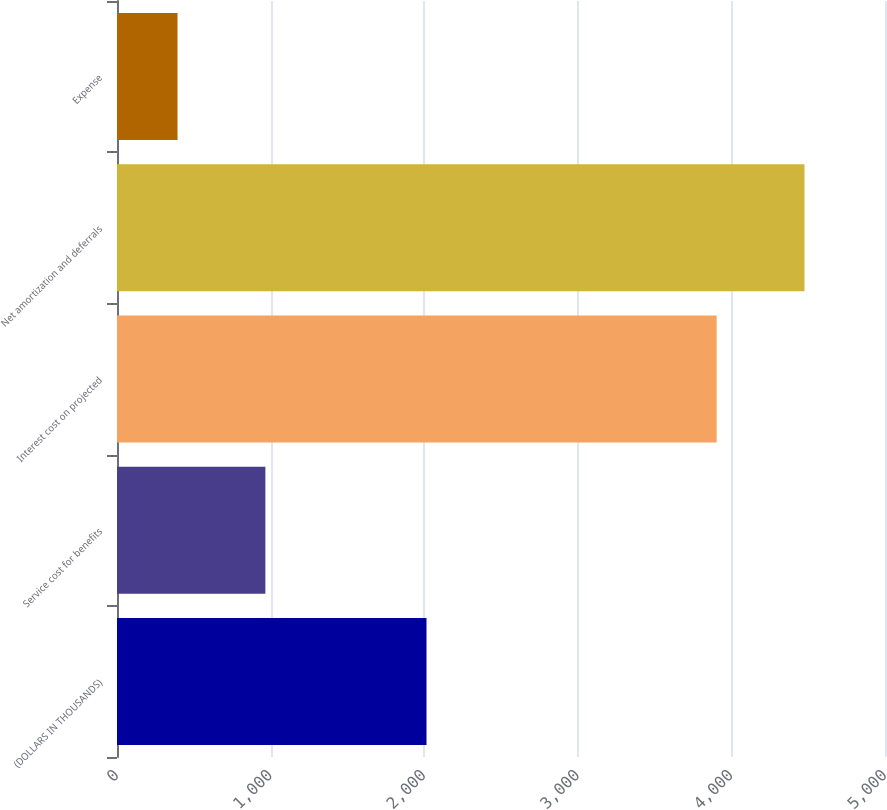<chart> <loc_0><loc_0><loc_500><loc_500><bar_chart><fcel>(DOLLARS IN THOUSANDS)<fcel>Service cost for benefits<fcel>Interest cost on projected<fcel>Net amortization and deferrals<fcel>Expense<nl><fcel>2015<fcel>966<fcel>3904<fcel>4476<fcel>394<nl></chart> 